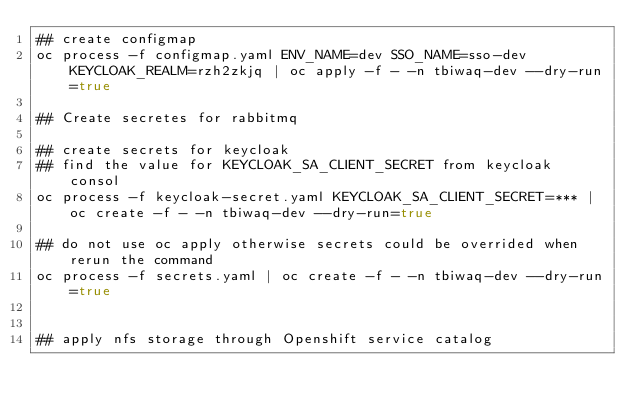Convert code to text. <code><loc_0><loc_0><loc_500><loc_500><_Bash_>## create configmap
oc process -f configmap.yaml ENV_NAME=dev SSO_NAME=sso-dev KEYCLOAK_REALM=rzh2zkjq | oc apply -f - -n tbiwaq-dev --dry-run=true

## Create secretes for rabbitmq

## create secrets for keycloak
## find the value for KEYCLOAK_SA_CLIENT_SECRET from keycloak consol
oc process -f keycloak-secret.yaml KEYCLOAK_SA_CLIENT_SECRET=*** | oc create -f - -n tbiwaq-dev --dry-run=true

## do not use oc apply otherwise secrets could be overrided when rerun the command
oc process -f secrets.yaml | oc create -f - -n tbiwaq-dev --dry-run=true


## apply nfs storage through Openshift service catalog

</code> 